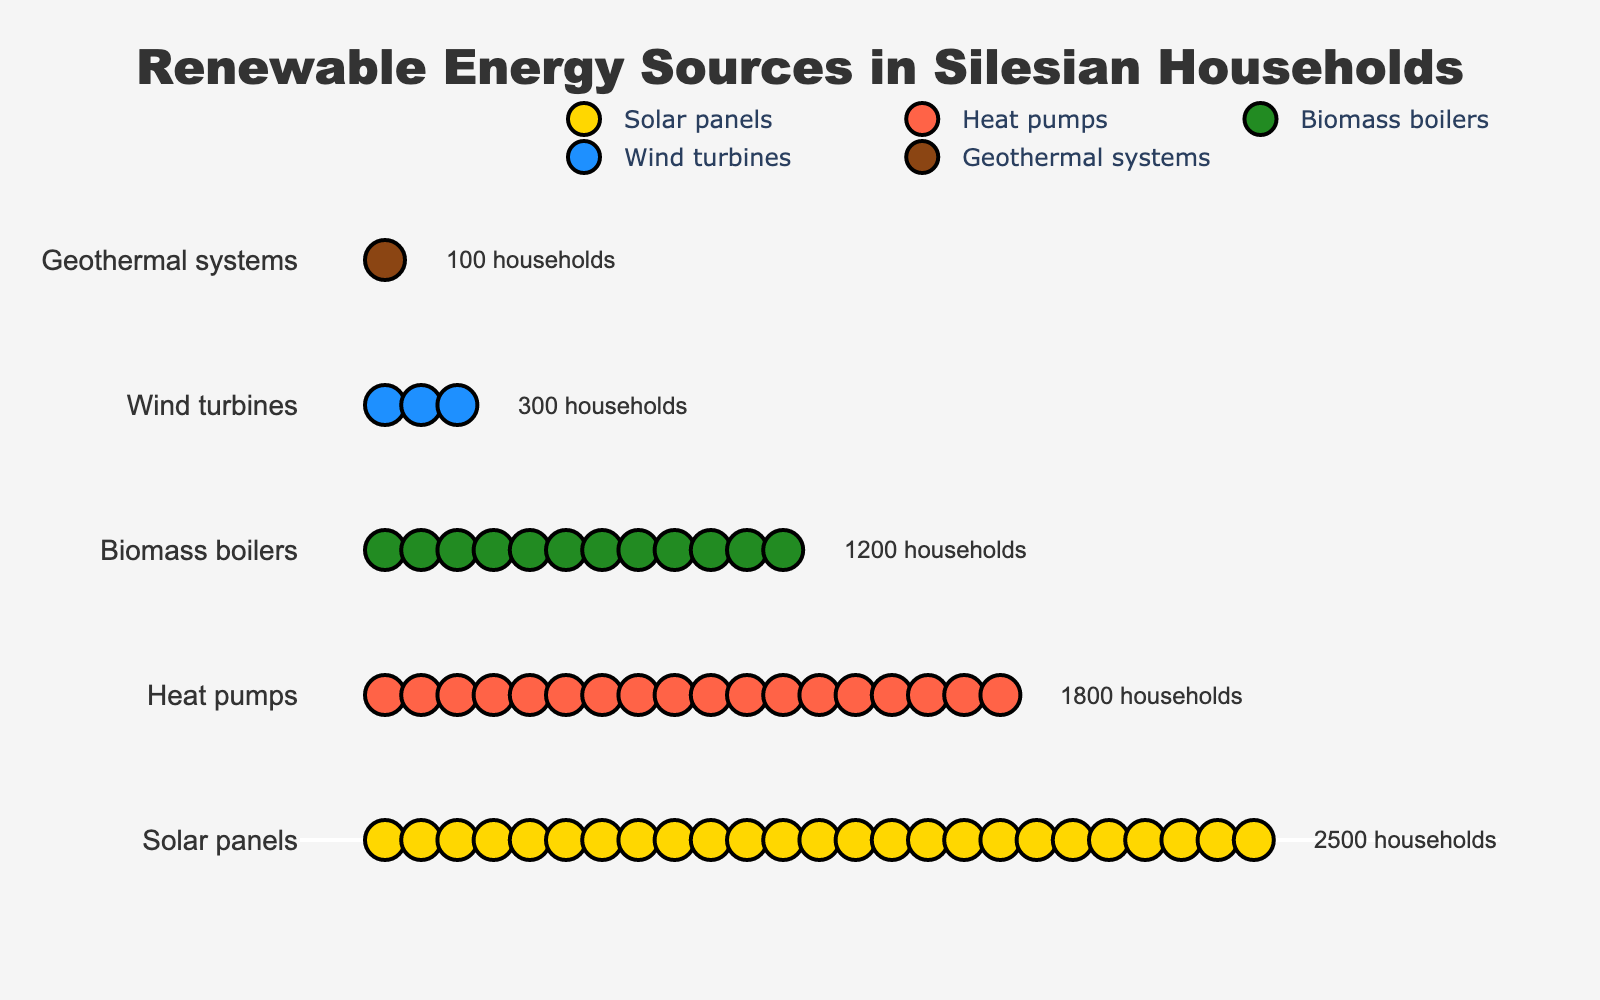Which renewable energy source is adopted by the most households in Silesia? By looking at the isotype plot, observe the number of icons representing each energy source. Solar panels have the highest number of icons, indicating the most households.
Answer: Solar panels How many households in total use Heat pumps and Biomass boilers? Add the number of households using Heat pumps and Biomass boilers. Heat pumps are used by 1800 households, and Biomass boilers by 1200 households. 1800 + 1200 = 3000.
Answer: 3000 Which energy source has the fewest households using it? Geothermal systems have the fewest icons in the isotype plot, indicating only 100 households.
Answer: Geothermal systems What's the difference in the number of households using Solar panels versus Wind turbines? Subtract the number of households using Wind turbines from those using Solar panels. 2500 (Solar panels) - 300 (Wind turbines) = 2200.
Answer: 2200 What's the average number of households using Solar panels, Heat pumps, and Biomass boilers? Add the number of households using these three sources and divide by 3. (2500 + 1800 + 1200) / 3 = 1833.33.
Answer: 1833.33 Which renewable energy sources have more than 1000 households using them? Identify sources with more than 1000 households: Solar panels (2500), Heat pumps (1800), and Biomass boilers (1200).
Answer: Solar panels, Heat pumps, Biomass boilers What's the sum of households using Wind turbines and Geothermal systems? Add the number of households using Wind turbines and Geothermal systems. 300 (Wind turbines) + 100 (Geothermal systems) = 400.
Answer: 400 Are there more households using Heat pumps than Biomass boilers? Compare the number of households: Heat pumps have 1800 households, Biomass boilers have 1200. Yes, 1800 > 1200.
Answer: Yes Identify the energy source that appears third in the list of the figure. The third source listed in the isotype plot is Biomass boilers.
Answer: Biomass boilers How many icons represent households using Solar panels in the plot? According to the provided code, each icon represents 100 households. For Solar panels, there are 2500 households, thus 2500 / 100 = 25 icons.
Answer: 25 